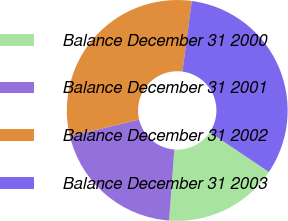Convert chart to OTSL. <chart><loc_0><loc_0><loc_500><loc_500><pie_chart><fcel>Balance December 31 2000<fcel>Balance December 31 2001<fcel>Balance December 31 2002<fcel>Balance December 31 2003<nl><fcel>16.77%<fcel>20.08%<fcel>30.85%<fcel>32.3%<nl></chart> 